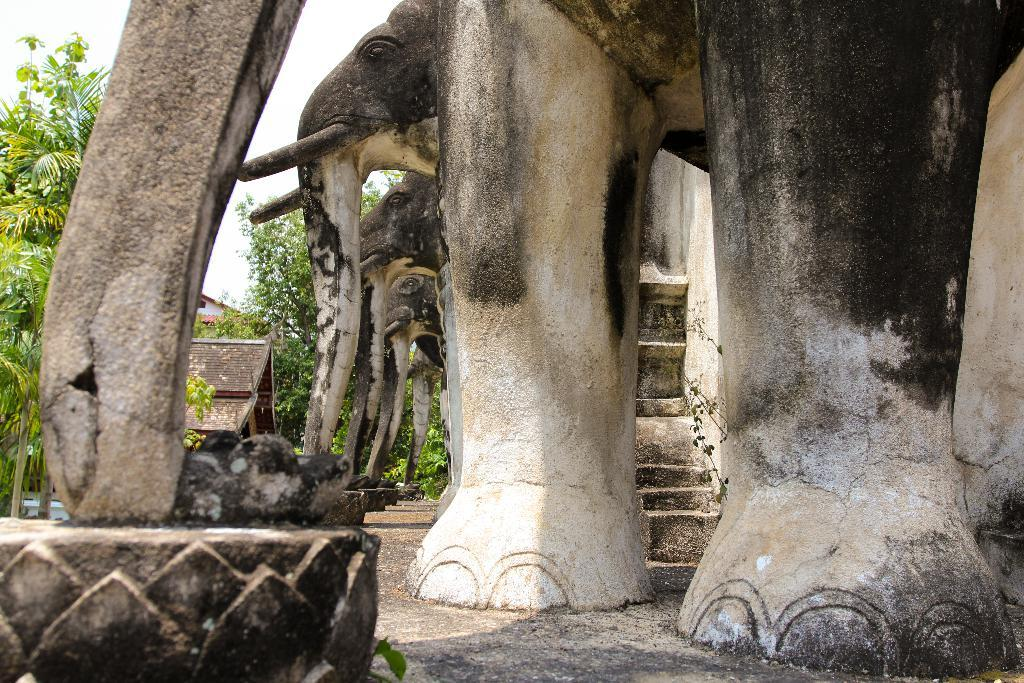What type of animals are depicted in the sculptures in the image? There are sculptures of elephants in the image. What can be seen on the right side of the image? There are trees and buildings on the right side of the image. What type of glass is used to create the sculptures in the image? There is no mention of glass being used to create the sculptures in the image; they are made of a different material. 